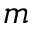Convert formula to latex. <formula><loc_0><loc_0><loc_500><loc_500>m</formula> 